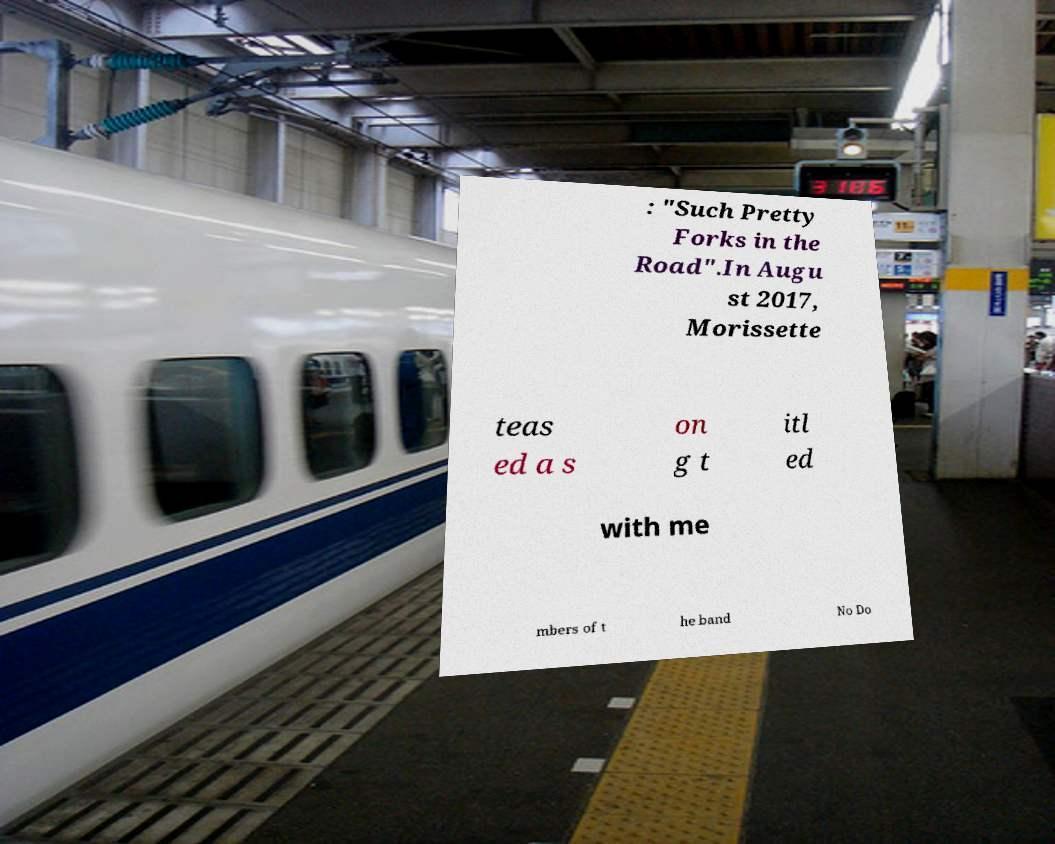Can you accurately transcribe the text from the provided image for me? : "Such Pretty Forks in the Road".In Augu st 2017, Morissette teas ed a s on g t itl ed with me mbers of t he band No Do 